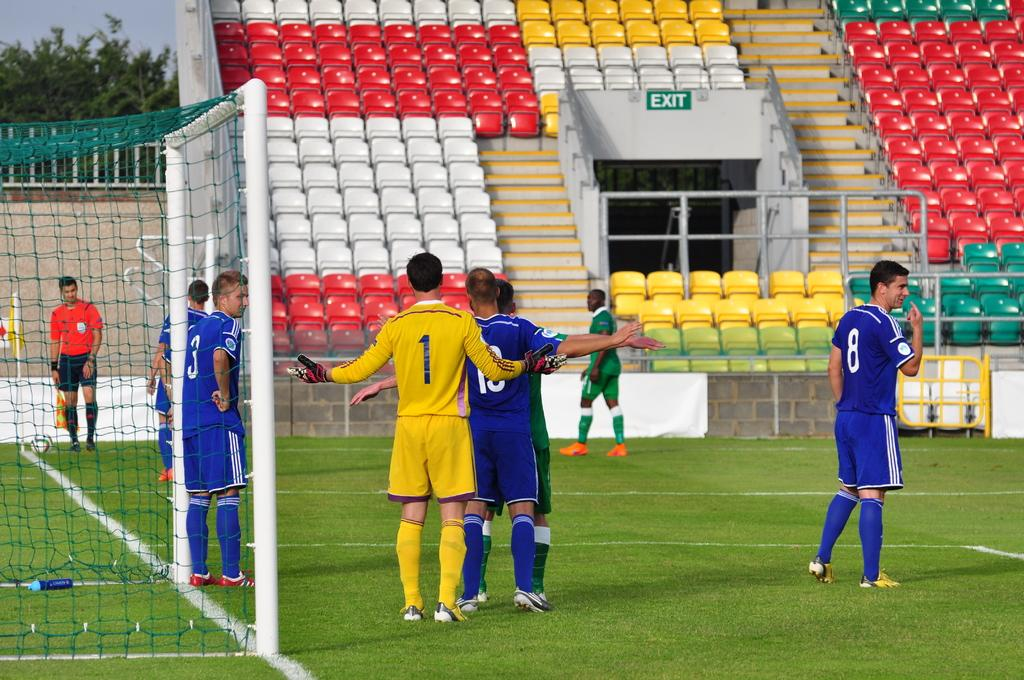<image>
Provide a brief description of the given image. Numbers 1 and 18 jostle for position for a corner kick. 